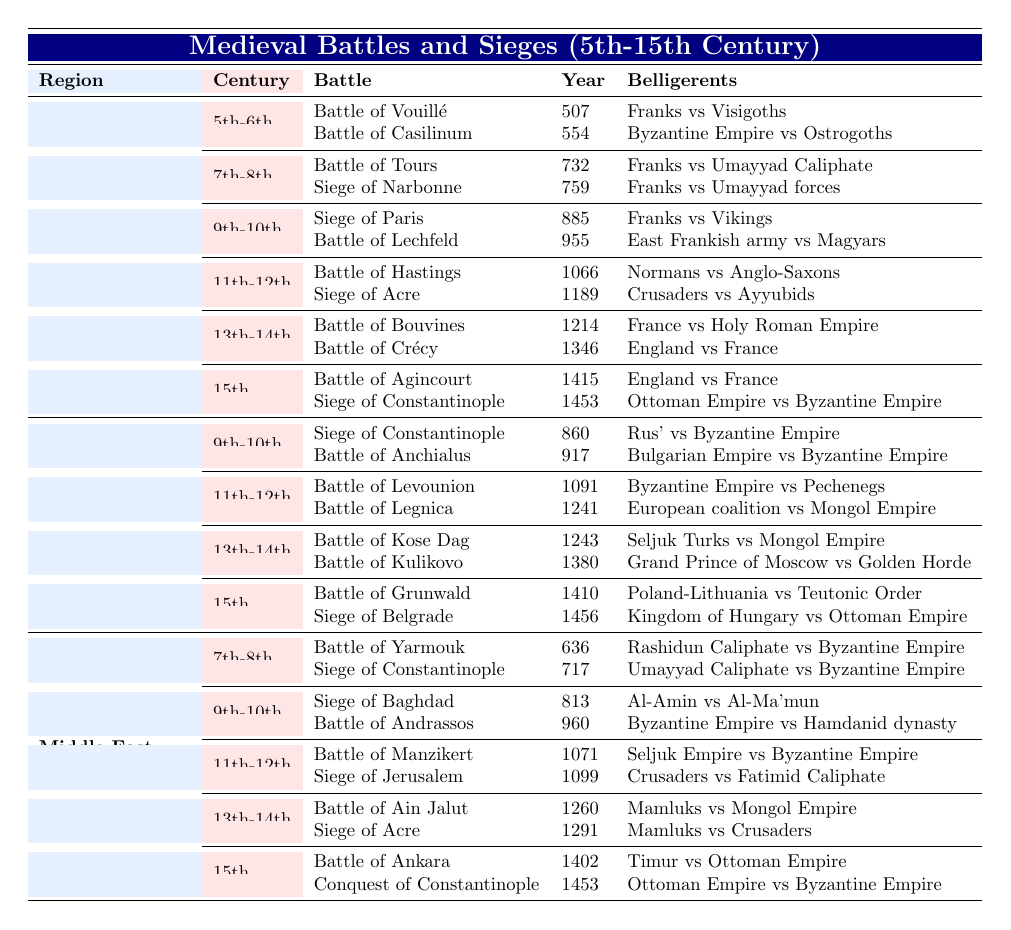What is the year of the Battle of Grunwald? The Battle of Grunwald is listed in the table under Eastern Europe, 15th Century, and the year provided is 1410.
Answer: 1410 How many battles are listed in the 13th-14th Century for Western Europe? In Western Europe, there are two battles listed for the 13th-14th Century: the Battle of Bouvines and the Battle of Crécy.
Answer: 2 Did the Ottoman Empire participate in any battles during the 15th Century according to the table? Yes, the Ottoman Empire is noted as a belligerent in both the Siege of Constantinople (1453) and the Battle of Ankara (1402), indicating their participation in battles during the 15th Century.
Answer: Yes Which battle occurred in the year 732? The battle that occurred in 732 is the Battle of Tours, listed in the table under Western Europe, 7th-8th Century.
Answer: Battle of Tours What is the total number of battles and sieges listed in the Middle East for the 11th-12th Century? In the Middle East for the 11th-12th Century, there are two entries: the Battle of Manzikert and the Siege of Jerusalem, summing up to a total of 2 battles/sieges.
Answer: 2 Which region had a siege that took place in the year 1456? The table indicates that the Siege of Belgrade took place in the year 1456, which is listed under Eastern Europe.
Answer: Eastern Europe Are there any battles listed in the table that occurred in the 5th Century? Yes, the Battle of Vouillé, which took place in the year 507, is listed under the 5th-6th Century in Western Europe.
Answer: Yes What is the earliest battle recorded in the table? The earliest battle recorded is the Battle of Vouillé in the year 507, found in the 5th-6th Century section under Western Europe.
Answer: Battle of Vouillé How many total entries are there for the 9th-10th Century in Eastern Europe? In Eastern Europe, there are four entries for the 9th-10th Century: the Siege of Constantinople (860) and the Battle of Anchialus (917), totaling 2 entries in that century.
Answer: 2 What was the conflict between the Grand Prince of Moscow and the Golden Horde? The conflict between the Grand Prince of Moscow and the Golden Horde is represented by the Battle of Kulikovo, which occurred in 1380 and is listed under Eastern Europe, 13th-14th Century.
Answer: Battle of Kulikovo 